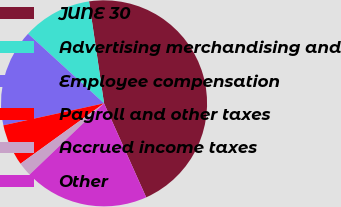Convert chart. <chart><loc_0><loc_0><loc_500><loc_500><pie_chart><fcel>JUNE 30<fcel>Advertising merchandising and<fcel>Employee compensation<fcel>Payroll and other taxes<fcel>Accrued income taxes<fcel>Other<nl><fcel>45.61%<fcel>10.88%<fcel>15.22%<fcel>6.54%<fcel>2.19%<fcel>19.56%<nl></chart> 